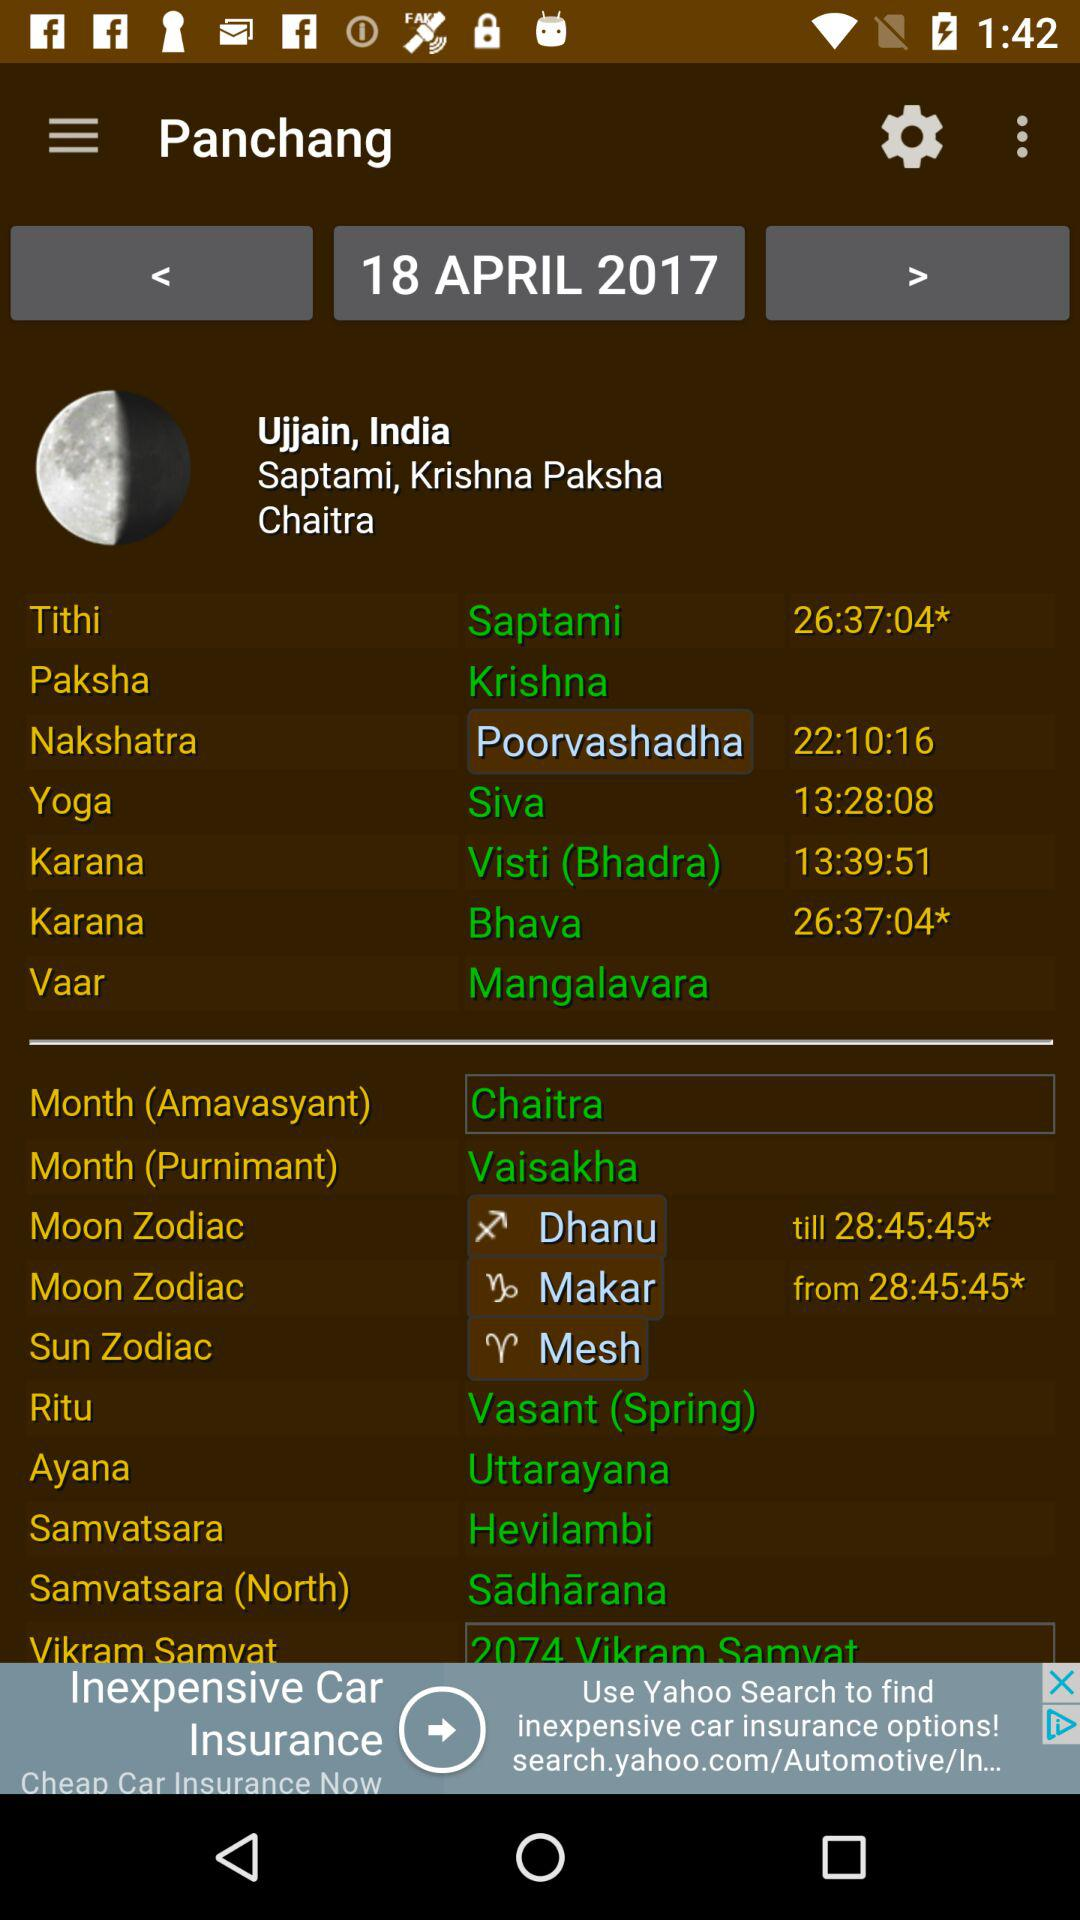What is the nakshatra? The nakshatra is Poorvashadha. 